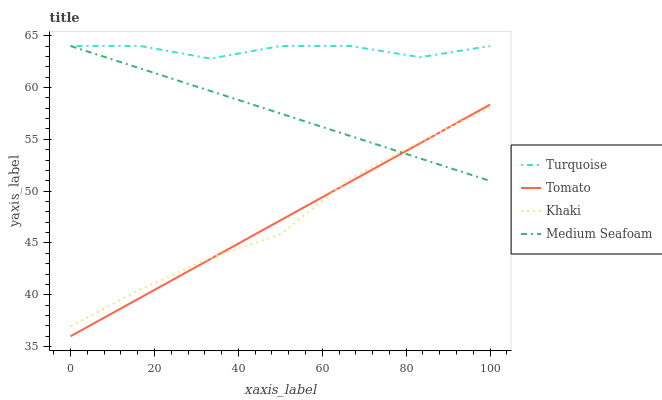Does Khaki have the minimum area under the curve?
Answer yes or no. No. Does Khaki have the maximum area under the curve?
Answer yes or no. No. Is Khaki the smoothest?
Answer yes or no. No. Is Khaki the roughest?
Answer yes or no. No. Does Khaki have the lowest value?
Answer yes or no. No. Does Khaki have the highest value?
Answer yes or no. No. Is Khaki less than Turquoise?
Answer yes or no. Yes. Is Turquoise greater than Tomato?
Answer yes or no. Yes. Does Khaki intersect Turquoise?
Answer yes or no. No. 